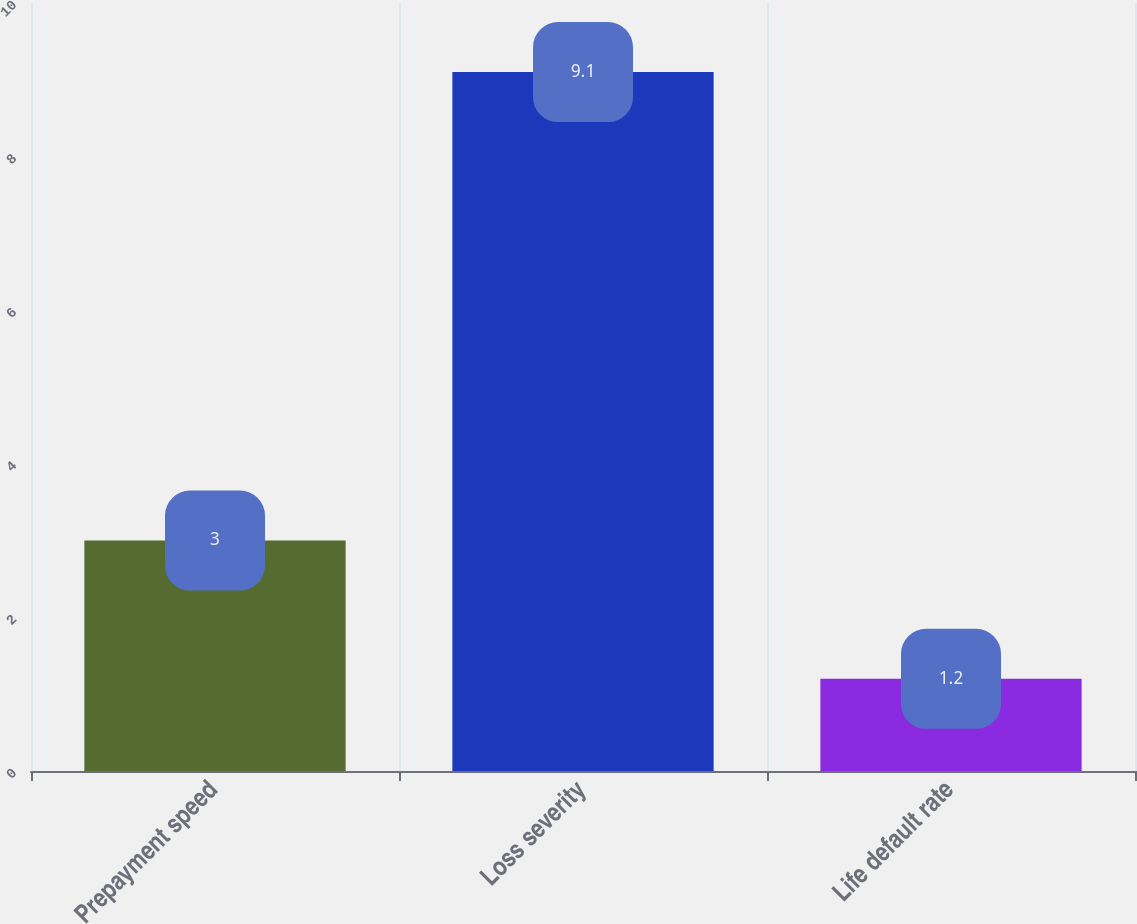Convert chart to OTSL. <chart><loc_0><loc_0><loc_500><loc_500><bar_chart><fcel>Prepayment speed<fcel>Loss severity<fcel>Life default rate<nl><fcel>3<fcel>9.1<fcel>1.2<nl></chart> 